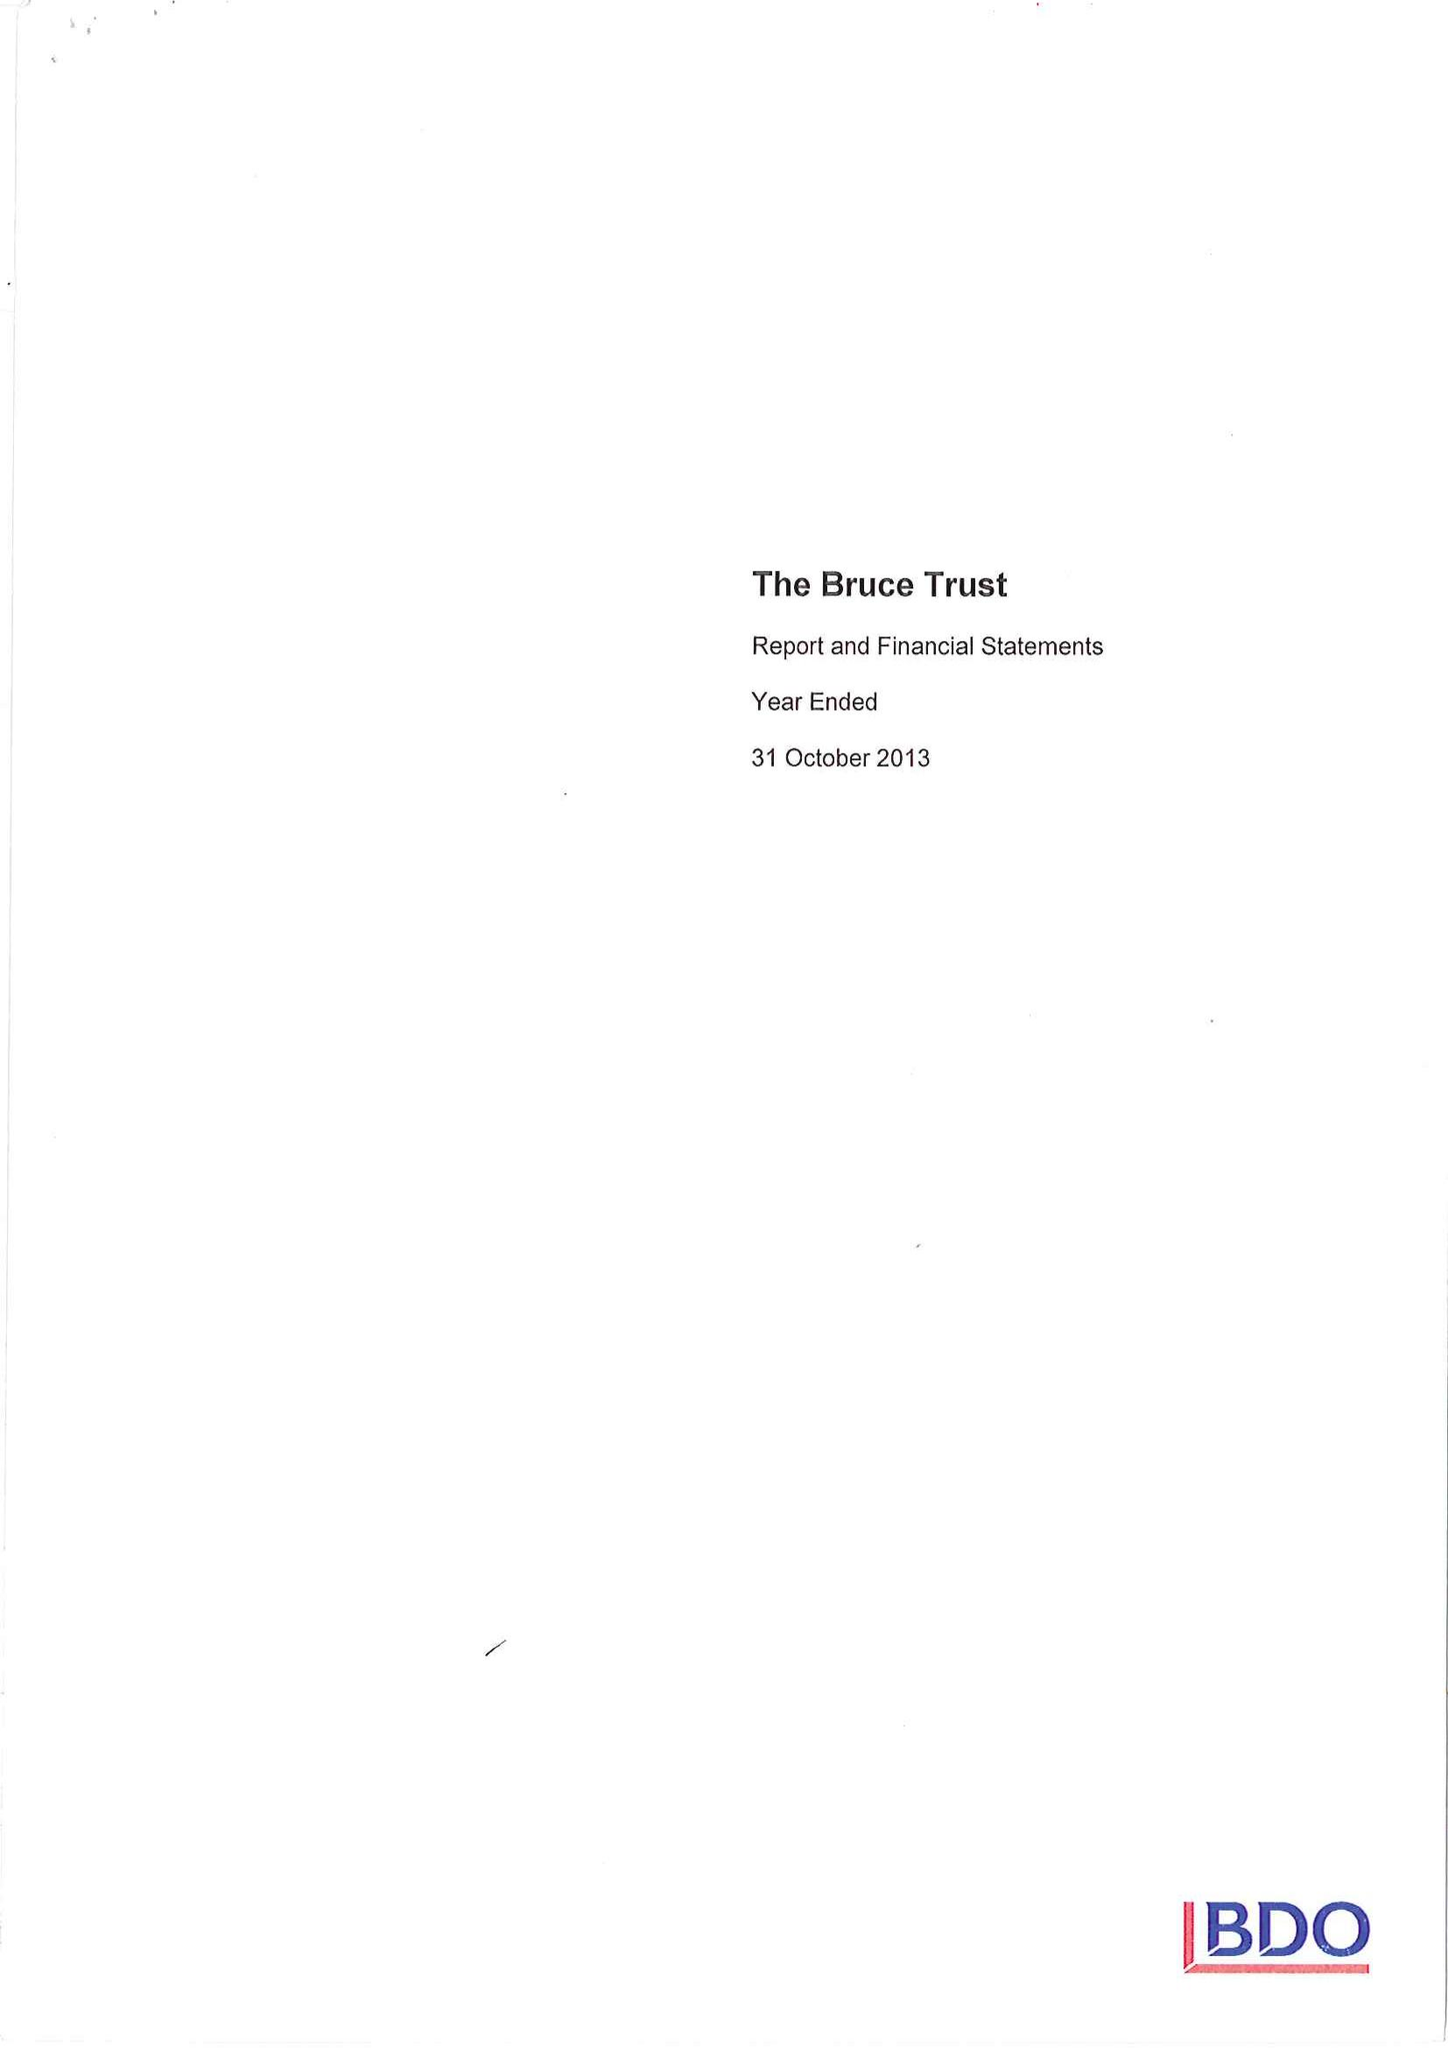What is the value for the address__post_town?
Answer the question using a single word or phrase. HUNGERFORD 